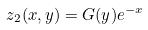<formula> <loc_0><loc_0><loc_500><loc_500>z _ { 2 } ( x , y ) = G ( y ) e ^ { - x }</formula> 